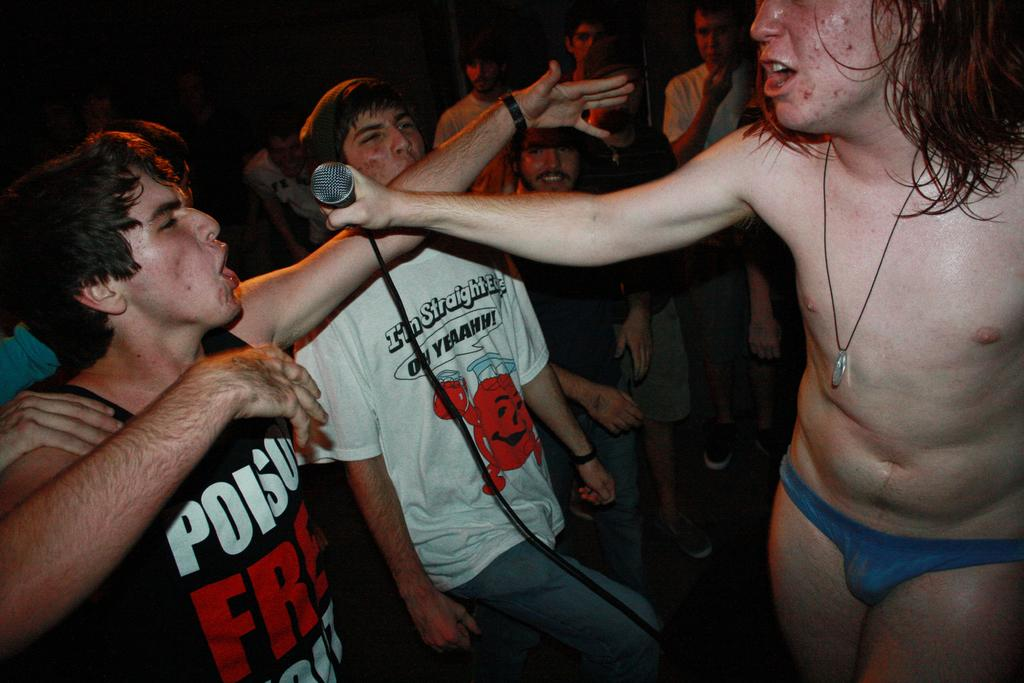How many people are in the image? There is a group of people in the image. Can you describe what one person is holding in the image? One person is holding a microphone with a cable in his hand. Where is the parcel being delivered in the image? There is no parcel present in the image. Is there a drain visible in the image? No, there is no drain visible in the image. 